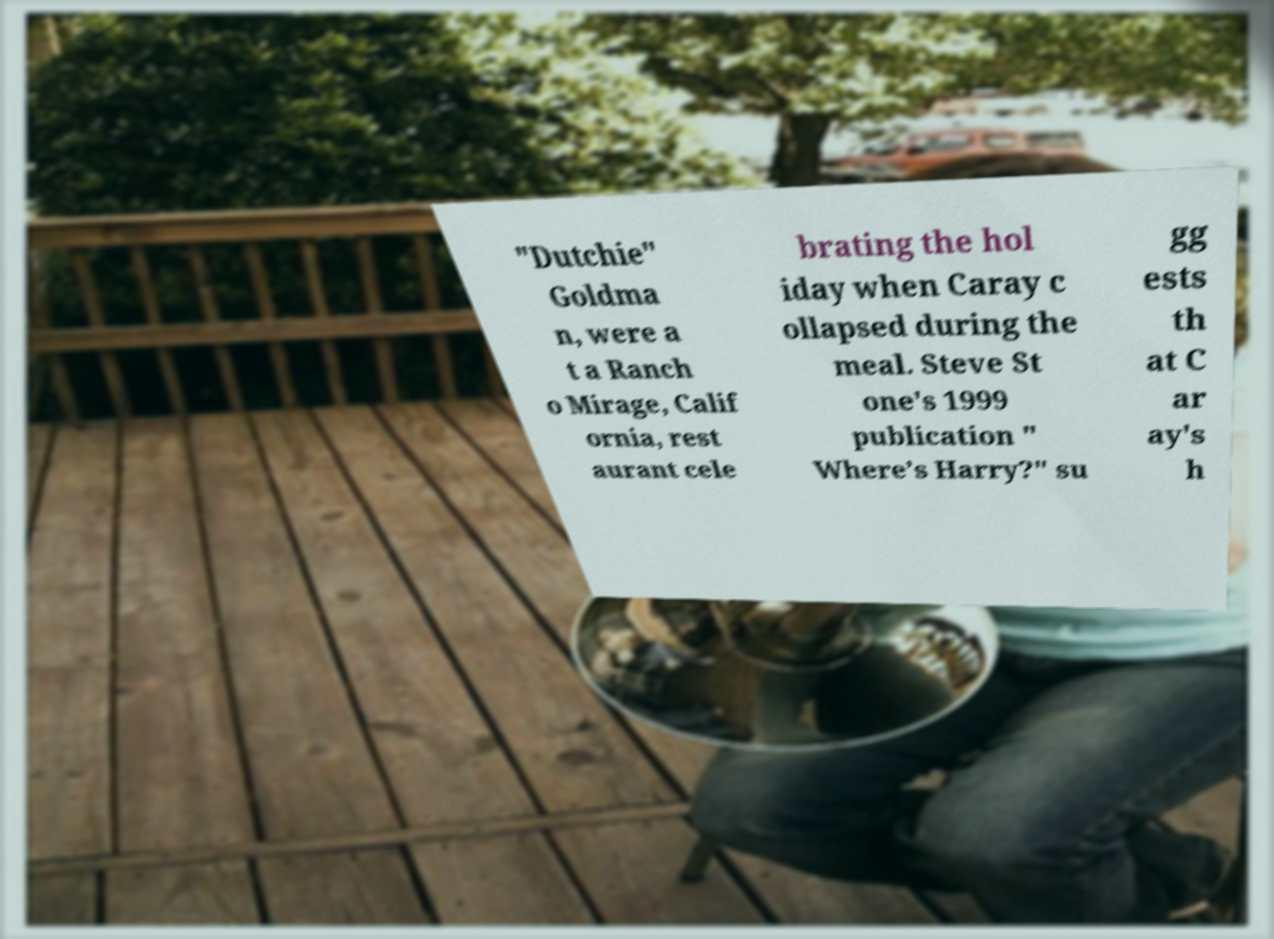What messages or text are displayed in this image? I need them in a readable, typed format. "Dutchie" Goldma n, were a t a Ranch o Mirage, Calif ornia, rest aurant cele brating the hol iday when Caray c ollapsed during the meal. Steve St one's 1999 publication " Where’s Harry?" su gg ests th at C ar ay's h 